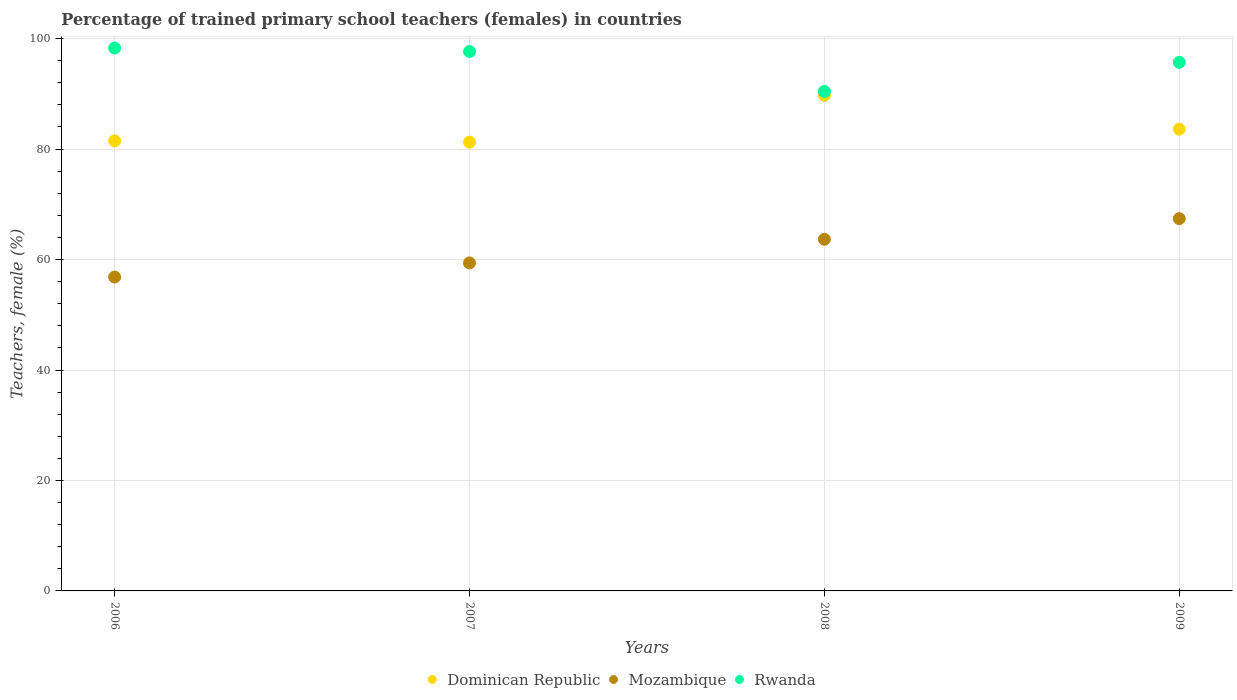What is the percentage of trained primary school teachers (females) in Dominican Republic in 2006?
Provide a short and direct response. 81.49. Across all years, what is the maximum percentage of trained primary school teachers (females) in Dominican Republic?
Offer a very short reply. 89.74. Across all years, what is the minimum percentage of trained primary school teachers (females) in Rwanda?
Keep it short and to the point. 90.44. In which year was the percentage of trained primary school teachers (females) in Mozambique maximum?
Keep it short and to the point. 2009. In which year was the percentage of trained primary school teachers (females) in Mozambique minimum?
Make the answer very short. 2006. What is the total percentage of trained primary school teachers (females) in Rwanda in the graph?
Offer a very short reply. 382.12. What is the difference between the percentage of trained primary school teachers (females) in Rwanda in 2006 and that in 2008?
Give a very brief answer. 7.86. What is the difference between the percentage of trained primary school teachers (females) in Dominican Republic in 2009 and the percentage of trained primary school teachers (females) in Mozambique in 2008?
Keep it short and to the point. 19.95. What is the average percentage of trained primary school teachers (females) in Rwanda per year?
Ensure brevity in your answer.  95.53. In the year 2007, what is the difference between the percentage of trained primary school teachers (females) in Dominican Republic and percentage of trained primary school teachers (females) in Rwanda?
Your response must be concise. -16.41. In how many years, is the percentage of trained primary school teachers (females) in Rwanda greater than 92 %?
Offer a terse response. 3. What is the ratio of the percentage of trained primary school teachers (females) in Dominican Republic in 2007 to that in 2008?
Your answer should be very brief. 0.91. What is the difference between the highest and the second highest percentage of trained primary school teachers (females) in Mozambique?
Your answer should be compact. 3.75. What is the difference between the highest and the lowest percentage of trained primary school teachers (females) in Mozambique?
Keep it short and to the point. 10.58. Is the sum of the percentage of trained primary school teachers (females) in Rwanda in 2007 and 2008 greater than the maximum percentage of trained primary school teachers (females) in Mozambique across all years?
Offer a very short reply. Yes. Does the percentage of trained primary school teachers (females) in Rwanda monotonically increase over the years?
Give a very brief answer. No. Is the percentage of trained primary school teachers (females) in Dominican Republic strictly greater than the percentage of trained primary school teachers (females) in Mozambique over the years?
Give a very brief answer. Yes. How many years are there in the graph?
Your response must be concise. 4. What is the difference between two consecutive major ticks on the Y-axis?
Keep it short and to the point. 20. Are the values on the major ticks of Y-axis written in scientific E-notation?
Provide a short and direct response. No. Does the graph contain any zero values?
Your answer should be compact. No. Does the graph contain grids?
Offer a very short reply. Yes. How many legend labels are there?
Provide a short and direct response. 3. What is the title of the graph?
Your response must be concise. Percentage of trained primary school teachers (females) in countries. What is the label or title of the X-axis?
Offer a very short reply. Years. What is the label or title of the Y-axis?
Your response must be concise. Teachers, female (%). What is the Teachers, female (%) in Dominican Republic in 2006?
Your answer should be very brief. 81.49. What is the Teachers, female (%) in Mozambique in 2006?
Your response must be concise. 56.83. What is the Teachers, female (%) of Rwanda in 2006?
Your answer should be compact. 98.3. What is the Teachers, female (%) of Dominican Republic in 2007?
Offer a terse response. 81.26. What is the Teachers, female (%) in Mozambique in 2007?
Your response must be concise. 59.39. What is the Teachers, female (%) in Rwanda in 2007?
Make the answer very short. 97.67. What is the Teachers, female (%) in Dominican Republic in 2008?
Your response must be concise. 89.74. What is the Teachers, female (%) of Mozambique in 2008?
Provide a short and direct response. 63.66. What is the Teachers, female (%) of Rwanda in 2008?
Your response must be concise. 90.44. What is the Teachers, female (%) in Dominican Republic in 2009?
Keep it short and to the point. 83.61. What is the Teachers, female (%) of Mozambique in 2009?
Make the answer very short. 67.41. What is the Teachers, female (%) in Rwanda in 2009?
Offer a very short reply. 95.71. Across all years, what is the maximum Teachers, female (%) of Dominican Republic?
Your answer should be very brief. 89.74. Across all years, what is the maximum Teachers, female (%) in Mozambique?
Provide a short and direct response. 67.41. Across all years, what is the maximum Teachers, female (%) in Rwanda?
Provide a short and direct response. 98.3. Across all years, what is the minimum Teachers, female (%) in Dominican Republic?
Your answer should be compact. 81.26. Across all years, what is the minimum Teachers, female (%) of Mozambique?
Your response must be concise. 56.83. Across all years, what is the minimum Teachers, female (%) of Rwanda?
Provide a succinct answer. 90.44. What is the total Teachers, female (%) in Dominican Republic in the graph?
Your answer should be compact. 336.1. What is the total Teachers, female (%) of Mozambique in the graph?
Keep it short and to the point. 247.29. What is the total Teachers, female (%) of Rwanda in the graph?
Your response must be concise. 382.12. What is the difference between the Teachers, female (%) in Dominican Republic in 2006 and that in 2007?
Offer a terse response. 0.23. What is the difference between the Teachers, female (%) of Mozambique in 2006 and that in 2007?
Give a very brief answer. -2.56. What is the difference between the Teachers, female (%) in Rwanda in 2006 and that in 2007?
Make the answer very short. 0.63. What is the difference between the Teachers, female (%) of Dominican Republic in 2006 and that in 2008?
Offer a terse response. -8.25. What is the difference between the Teachers, female (%) in Mozambique in 2006 and that in 2008?
Make the answer very short. -6.83. What is the difference between the Teachers, female (%) in Rwanda in 2006 and that in 2008?
Give a very brief answer. 7.86. What is the difference between the Teachers, female (%) in Dominican Republic in 2006 and that in 2009?
Keep it short and to the point. -2.12. What is the difference between the Teachers, female (%) of Mozambique in 2006 and that in 2009?
Keep it short and to the point. -10.58. What is the difference between the Teachers, female (%) in Rwanda in 2006 and that in 2009?
Offer a very short reply. 2.59. What is the difference between the Teachers, female (%) of Dominican Republic in 2007 and that in 2008?
Provide a succinct answer. -8.48. What is the difference between the Teachers, female (%) in Mozambique in 2007 and that in 2008?
Make the answer very short. -4.27. What is the difference between the Teachers, female (%) of Rwanda in 2007 and that in 2008?
Your answer should be compact. 7.23. What is the difference between the Teachers, female (%) in Dominican Republic in 2007 and that in 2009?
Provide a succinct answer. -2.35. What is the difference between the Teachers, female (%) of Mozambique in 2007 and that in 2009?
Make the answer very short. -8.02. What is the difference between the Teachers, female (%) in Rwanda in 2007 and that in 2009?
Provide a short and direct response. 1.96. What is the difference between the Teachers, female (%) of Dominican Republic in 2008 and that in 2009?
Keep it short and to the point. 6.13. What is the difference between the Teachers, female (%) in Mozambique in 2008 and that in 2009?
Provide a succinct answer. -3.75. What is the difference between the Teachers, female (%) in Rwanda in 2008 and that in 2009?
Make the answer very short. -5.27. What is the difference between the Teachers, female (%) in Dominican Republic in 2006 and the Teachers, female (%) in Mozambique in 2007?
Your answer should be very brief. 22.1. What is the difference between the Teachers, female (%) of Dominican Republic in 2006 and the Teachers, female (%) of Rwanda in 2007?
Offer a terse response. -16.18. What is the difference between the Teachers, female (%) of Mozambique in 2006 and the Teachers, female (%) of Rwanda in 2007?
Offer a terse response. -40.84. What is the difference between the Teachers, female (%) of Dominican Republic in 2006 and the Teachers, female (%) of Mozambique in 2008?
Give a very brief answer. 17.83. What is the difference between the Teachers, female (%) of Dominican Republic in 2006 and the Teachers, female (%) of Rwanda in 2008?
Provide a succinct answer. -8.95. What is the difference between the Teachers, female (%) in Mozambique in 2006 and the Teachers, female (%) in Rwanda in 2008?
Make the answer very short. -33.61. What is the difference between the Teachers, female (%) of Dominican Republic in 2006 and the Teachers, female (%) of Mozambique in 2009?
Give a very brief answer. 14.08. What is the difference between the Teachers, female (%) in Dominican Republic in 2006 and the Teachers, female (%) in Rwanda in 2009?
Offer a very short reply. -14.22. What is the difference between the Teachers, female (%) in Mozambique in 2006 and the Teachers, female (%) in Rwanda in 2009?
Give a very brief answer. -38.88. What is the difference between the Teachers, female (%) in Dominican Republic in 2007 and the Teachers, female (%) in Mozambique in 2008?
Provide a short and direct response. 17.6. What is the difference between the Teachers, female (%) of Dominican Republic in 2007 and the Teachers, female (%) of Rwanda in 2008?
Give a very brief answer. -9.18. What is the difference between the Teachers, female (%) in Mozambique in 2007 and the Teachers, female (%) in Rwanda in 2008?
Make the answer very short. -31.05. What is the difference between the Teachers, female (%) of Dominican Republic in 2007 and the Teachers, female (%) of Mozambique in 2009?
Make the answer very short. 13.85. What is the difference between the Teachers, female (%) of Dominican Republic in 2007 and the Teachers, female (%) of Rwanda in 2009?
Make the answer very short. -14.45. What is the difference between the Teachers, female (%) in Mozambique in 2007 and the Teachers, female (%) in Rwanda in 2009?
Make the answer very short. -36.32. What is the difference between the Teachers, female (%) in Dominican Republic in 2008 and the Teachers, female (%) in Mozambique in 2009?
Offer a terse response. 22.33. What is the difference between the Teachers, female (%) of Dominican Republic in 2008 and the Teachers, female (%) of Rwanda in 2009?
Your answer should be very brief. -5.97. What is the difference between the Teachers, female (%) in Mozambique in 2008 and the Teachers, female (%) in Rwanda in 2009?
Your response must be concise. -32.05. What is the average Teachers, female (%) in Dominican Republic per year?
Ensure brevity in your answer.  84.02. What is the average Teachers, female (%) of Mozambique per year?
Provide a succinct answer. 61.82. What is the average Teachers, female (%) of Rwanda per year?
Ensure brevity in your answer.  95.53. In the year 2006, what is the difference between the Teachers, female (%) of Dominican Republic and Teachers, female (%) of Mozambique?
Offer a terse response. 24.66. In the year 2006, what is the difference between the Teachers, female (%) in Dominican Republic and Teachers, female (%) in Rwanda?
Your answer should be very brief. -16.81. In the year 2006, what is the difference between the Teachers, female (%) in Mozambique and Teachers, female (%) in Rwanda?
Make the answer very short. -41.47. In the year 2007, what is the difference between the Teachers, female (%) of Dominican Republic and Teachers, female (%) of Mozambique?
Provide a succinct answer. 21.87. In the year 2007, what is the difference between the Teachers, female (%) in Dominican Republic and Teachers, female (%) in Rwanda?
Offer a terse response. -16.41. In the year 2007, what is the difference between the Teachers, female (%) of Mozambique and Teachers, female (%) of Rwanda?
Make the answer very short. -38.28. In the year 2008, what is the difference between the Teachers, female (%) in Dominican Republic and Teachers, female (%) in Mozambique?
Your answer should be very brief. 26.08. In the year 2008, what is the difference between the Teachers, female (%) in Dominican Republic and Teachers, female (%) in Rwanda?
Your response must be concise. -0.7. In the year 2008, what is the difference between the Teachers, female (%) in Mozambique and Teachers, female (%) in Rwanda?
Keep it short and to the point. -26.78. In the year 2009, what is the difference between the Teachers, female (%) of Dominican Republic and Teachers, female (%) of Mozambique?
Offer a very short reply. 16.2. In the year 2009, what is the difference between the Teachers, female (%) of Dominican Republic and Teachers, female (%) of Rwanda?
Keep it short and to the point. -12.1. In the year 2009, what is the difference between the Teachers, female (%) of Mozambique and Teachers, female (%) of Rwanda?
Offer a terse response. -28.3. What is the ratio of the Teachers, female (%) of Mozambique in 2006 to that in 2007?
Your answer should be very brief. 0.96. What is the ratio of the Teachers, female (%) in Rwanda in 2006 to that in 2007?
Offer a terse response. 1.01. What is the ratio of the Teachers, female (%) in Dominican Republic in 2006 to that in 2008?
Your response must be concise. 0.91. What is the ratio of the Teachers, female (%) in Mozambique in 2006 to that in 2008?
Your answer should be very brief. 0.89. What is the ratio of the Teachers, female (%) of Rwanda in 2006 to that in 2008?
Provide a short and direct response. 1.09. What is the ratio of the Teachers, female (%) of Dominican Republic in 2006 to that in 2009?
Provide a succinct answer. 0.97. What is the ratio of the Teachers, female (%) in Mozambique in 2006 to that in 2009?
Provide a short and direct response. 0.84. What is the ratio of the Teachers, female (%) in Rwanda in 2006 to that in 2009?
Provide a short and direct response. 1.03. What is the ratio of the Teachers, female (%) in Dominican Republic in 2007 to that in 2008?
Offer a very short reply. 0.91. What is the ratio of the Teachers, female (%) in Mozambique in 2007 to that in 2008?
Ensure brevity in your answer.  0.93. What is the ratio of the Teachers, female (%) of Rwanda in 2007 to that in 2008?
Give a very brief answer. 1.08. What is the ratio of the Teachers, female (%) of Dominican Republic in 2007 to that in 2009?
Provide a succinct answer. 0.97. What is the ratio of the Teachers, female (%) in Mozambique in 2007 to that in 2009?
Offer a terse response. 0.88. What is the ratio of the Teachers, female (%) of Rwanda in 2007 to that in 2009?
Your answer should be compact. 1.02. What is the ratio of the Teachers, female (%) in Dominican Republic in 2008 to that in 2009?
Provide a succinct answer. 1.07. What is the ratio of the Teachers, female (%) of Mozambique in 2008 to that in 2009?
Keep it short and to the point. 0.94. What is the ratio of the Teachers, female (%) in Rwanda in 2008 to that in 2009?
Provide a succinct answer. 0.94. What is the difference between the highest and the second highest Teachers, female (%) of Dominican Republic?
Make the answer very short. 6.13. What is the difference between the highest and the second highest Teachers, female (%) of Mozambique?
Your response must be concise. 3.75. What is the difference between the highest and the second highest Teachers, female (%) of Rwanda?
Offer a terse response. 0.63. What is the difference between the highest and the lowest Teachers, female (%) of Dominican Republic?
Your response must be concise. 8.48. What is the difference between the highest and the lowest Teachers, female (%) in Mozambique?
Offer a very short reply. 10.58. What is the difference between the highest and the lowest Teachers, female (%) in Rwanda?
Offer a very short reply. 7.86. 